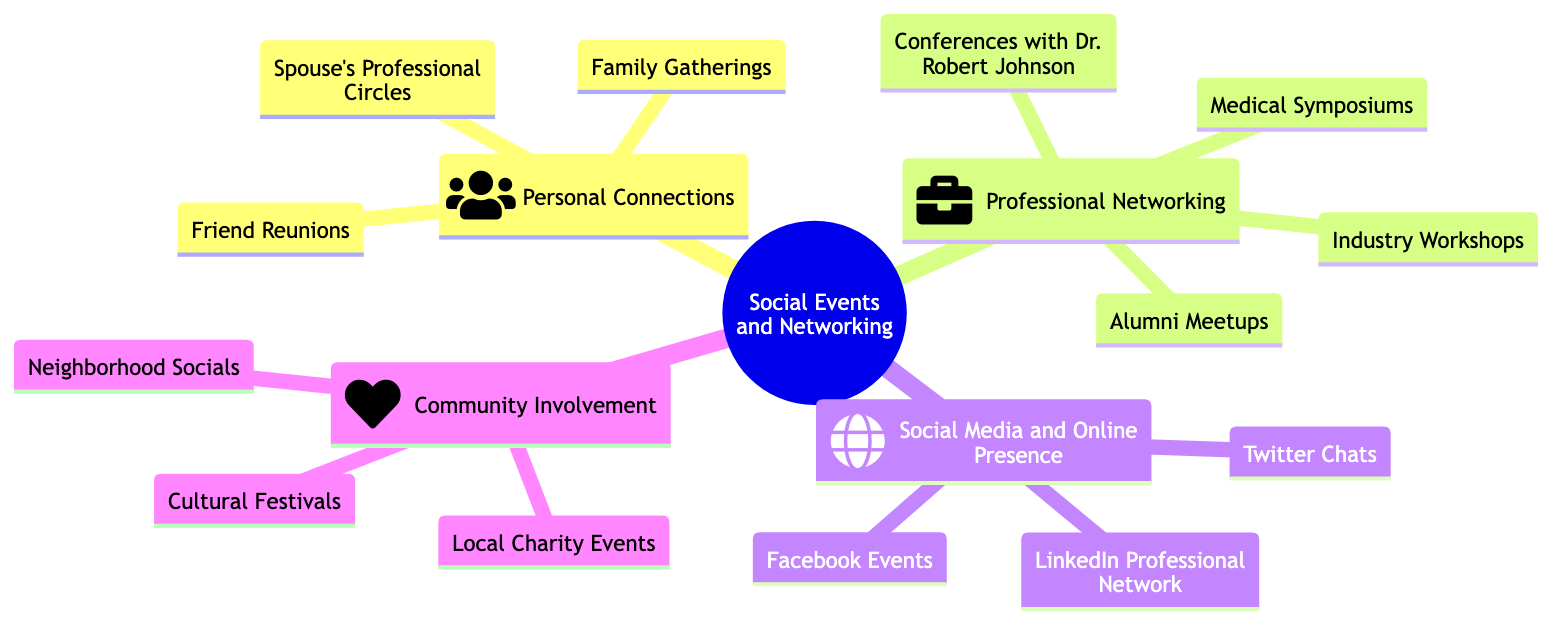What are the main subtopics under "Social Events and Networking"? The main subtopics under "Social Events and Networking" are listed directly below the main topic within the diagram and include Personal Connections, Professional Networking, Social Media and Online Presence, and Community Involvement.
Answer: Personal Connections, Professional Networking, Social Media and Online Presence, Community Involvement How many elements are listed under "Professional Networking"? To find the number of elements, I count the items listed under the "Professional Networking" node. There are four elements: Conferences with Dr. Robert Johnson, Medical Symposiums, Alumni Meetups, and Industry Workshops.
Answer: 4 Which element under "Personal Connections" refers to social events involving family? The diagram provides three elements under "Personal Connections," and among them, "Family Gatherings" specifically refers to social events involving family.
Answer: Family Gatherings What type of events are included in "Community Involvement"? Under "Community Involvement," three distinct types of events are mentioned: Local Charity Events, Neighborhood Socials, and Cultural Festivals, which focus on community engagement.
Answer: Local Charity Events, Neighborhood Socials, Cultural Festivals Which element is associated with Dr. Robert Johnson? The diagram indicates that "Conferences with Dr. Robert Johnson" is specifically listed under the "Professional Networking" section, denoting his involvement in those events.
Answer: Conferences with Dr. Robert Johnson What category includes "LinkedIn Professional Network"? To determine the category, I look for the node or section that features "LinkedIn Professional Network." It is found under "Social Media and Online Presence," which focuses on online networking platforms.
Answer: Social Media and Online Presence Are there any mentions of social events that relate to culture? I review the diagram for elements that pertain to culture, and I find that "Cultural Festivals" is included in the "Community Involvement" subtopic, confirming that cultural social events are represented.
Answer: Cultural Festivals How many elements are listed under "Social Media and Online Presence"? I count the items listed under "Social Media and Online Presence" within the diagram, which includes three elements: LinkedIn Professional Network, Facebook Events, and Twitter Chats, totaling three elements.
Answer: 3 Which subtopic includes "Neighborhood Socials"? By examining the diagram, I identify that "Neighborhood Socials" is part of the "Community Involvement" subtopic, pointing to events that promote neighborly interactions.
Answer: Community Involvement 